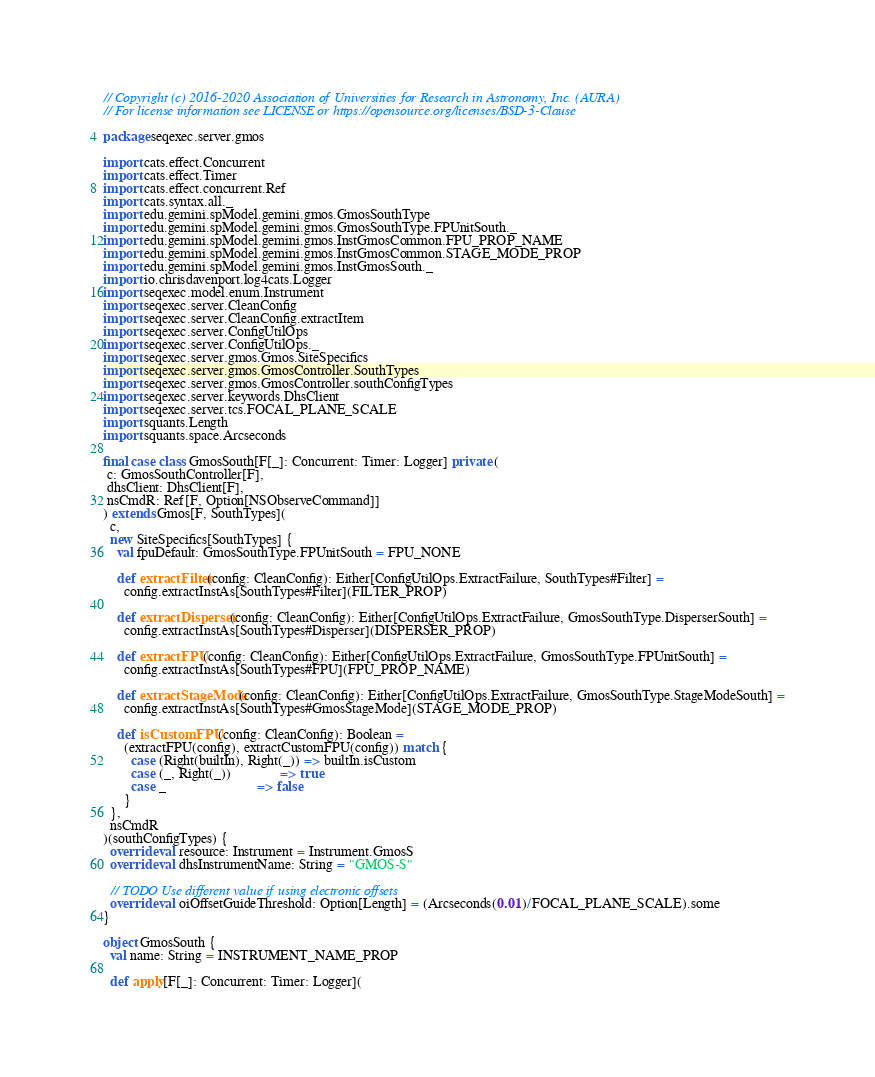Convert code to text. <code><loc_0><loc_0><loc_500><loc_500><_Scala_>// Copyright (c) 2016-2020 Association of Universities for Research in Astronomy, Inc. (AURA)
// For license information see LICENSE or https://opensource.org/licenses/BSD-3-Clause

package seqexec.server.gmos

import cats.effect.Concurrent
import cats.effect.Timer
import cats.effect.concurrent.Ref
import cats.syntax.all._
import edu.gemini.spModel.gemini.gmos.GmosSouthType
import edu.gemini.spModel.gemini.gmos.GmosSouthType.FPUnitSouth._
import edu.gemini.spModel.gemini.gmos.InstGmosCommon.FPU_PROP_NAME
import edu.gemini.spModel.gemini.gmos.InstGmosCommon.STAGE_MODE_PROP
import edu.gemini.spModel.gemini.gmos.InstGmosSouth._
import io.chrisdavenport.log4cats.Logger
import seqexec.model.enum.Instrument
import seqexec.server.CleanConfig
import seqexec.server.CleanConfig.extractItem
import seqexec.server.ConfigUtilOps
import seqexec.server.ConfigUtilOps._
import seqexec.server.gmos.Gmos.SiteSpecifics
import seqexec.server.gmos.GmosController.SouthTypes
import seqexec.server.gmos.GmosController.southConfigTypes
import seqexec.server.keywords.DhsClient
import seqexec.server.tcs.FOCAL_PLANE_SCALE
import squants.Length
import squants.space.Arcseconds

final case class GmosSouth[F[_]: Concurrent: Timer: Logger] private (
 c: GmosSouthController[F],
 dhsClient: DhsClient[F],
 nsCmdR: Ref[F, Option[NSObserveCommand]]
) extends Gmos[F, SouthTypes](
  c,
  new SiteSpecifics[SouthTypes] {
    val fpuDefault: GmosSouthType.FPUnitSouth = FPU_NONE

    def extractFilter(config: CleanConfig): Either[ConfigUtilOps.ExtractFailure, SouthTypes#Filter] =
      config.extractInstAs[SouthTypes#Filter](FILTER_PROP)

    def extractDisperser(config: CleanConfig): Either[ConfigUtilOps.ExtractFailure, GmosSouthType.DisperserSouth] =
      config.extractInstAs[SouthTypes#Disperser](DISPERSER_PROP)

    def extractFPU(config: CleanConfig): Either[ConfigUtilOps.ExtractFailure, GmosSouthType.FPUnitSouth] =
      config.extractInstAs[SouthTypes#FPU](FPU_PROP_NAME)

    def extractStageMode(config: CleanConfig): Either[ConfigUtilOps.ExtractFailure, GmosSouthType.StageModeSouth] =
      config.extractInstAs[SouthTypes#GmosStageMode](STAGE_MODE_PROP)

    def isCustomFPU(config: CleanConfig): Boolean =
      (extractFPU(config), extractCustomFPU(config)) match {
        case (Right(builtIn), Right(_)) => builtIn.isCustom
        case (_, Right(_))              => true
        case _                          => false
      }
  },
  nsCmdR
)(southConfigTypes) {
  override val resource: Instrument = Instrument.GmosS
  override val dhsInstrumentName: String = "GMOS-S"

  // TODO Use different value if using electronic offsets
  override val oiOffsetGuideThreshold: Option[Length] = (Arcseconds(0.01)/FOCAL_PLANE_SCALE).some
}

object GmosSouth {
  val name: String = INSTRUMENT_NAME_PROP

  def apply[F[_]: Concurrent: Timer: Logger](</code> 